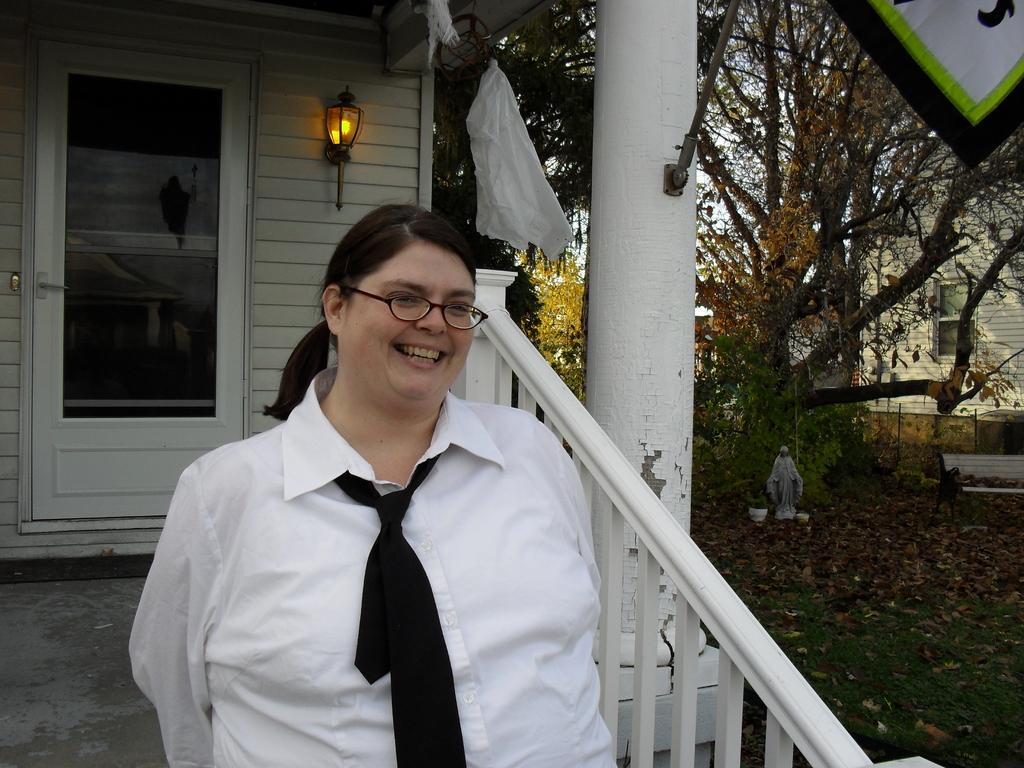What is the main subject of the image? There is a woman standing in front of a house in the image. What can be seen in the background of the image? There are trees in the background of the image. Are there any other objects or features in the image besides the woman and the house? Yes, there is a sculpture under the tree. How many brothers does the woman have, according to the image? The image does not provide any information about the woman's brothers, so we cannot determine their number from the image. What type of beam is holding up the tree in the image? There is no beam visible in the image; the tree appears to be standing on its own. 